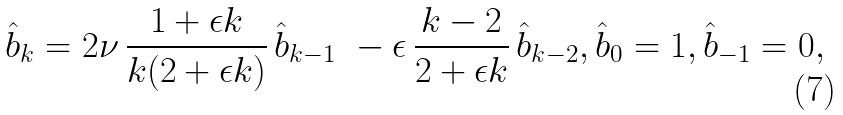<formula> <loc_0><loc_0><loc_500><loc_500>\hat { b } _ { k } = 2 \nu \, \frac { 1 + \epsilon k } { k ( 2 + \epsilon k ) } \, \hat { b } _ { k - 1 } \ - \epsilon \, \frac { k - 2 } { 2 + \epsilon k } \, \hat { b } _ { k - 2 } , \hat { b } _ { 0 } = 1 , \hat { b } _ { - 1 } = 0 ,</formula> 